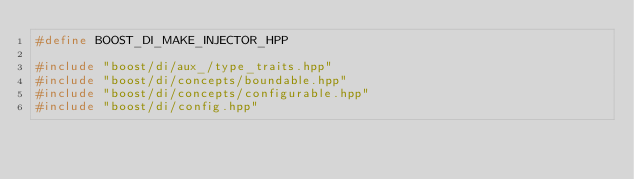Convert code to text. <code><loc_0><loc_0><loc_500><loc_500><_C++_>#define BOOST_DI_MAKE_INJECTOR_HPP

#include "boost/di/aux_/type_traits.hpp"
#include "boost/di/concepts/boundable.hpp"
#include "boost/di/concepts/configurable.hpp"
#include "boost/di/config.hpp"</code> 